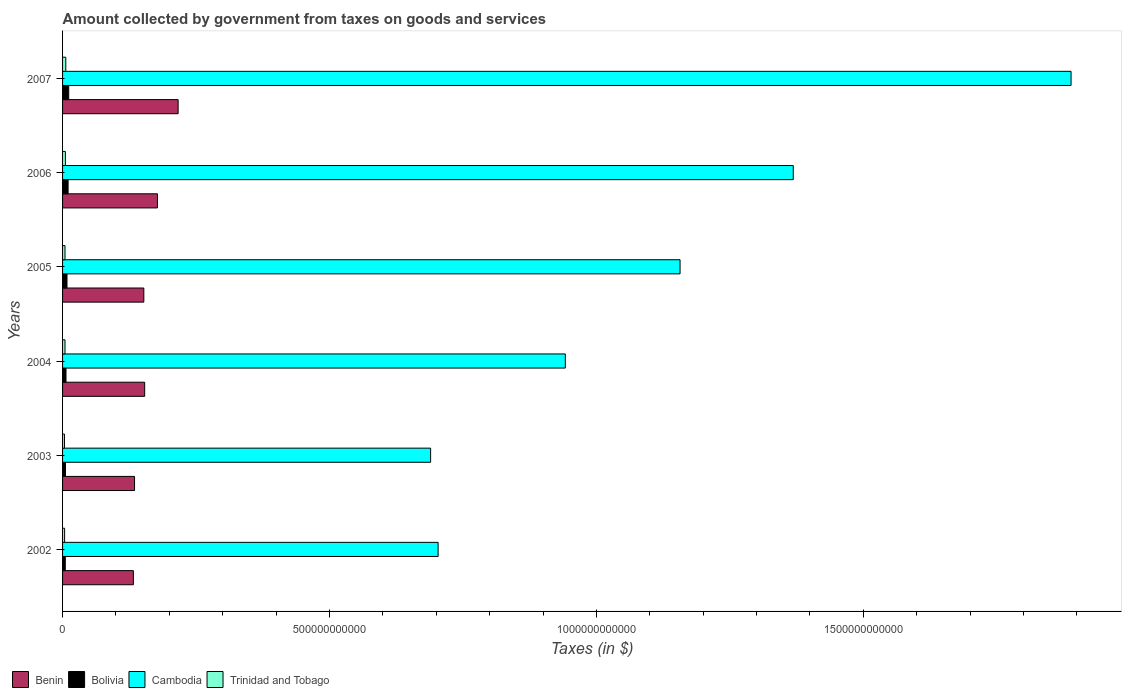How many groups of bars are there?
Ensure brevity in your answer.  6. How many bars are there on the 4th tick from the top?
Provide a short and direct response. 4. How many bars are there on the 3rd tick from the bottom?
Your answer should be very brief. 4. What is the amount collected by government from taxes on goods and services in Bolivia in 2002?
Provide a short and direct response. 5.11e+09. Across all years, what is the maximum amount collected by government from taxes on goods and services in Bolivia?
Provide a short and direct response. 1.15e+1. Across all years, what is the minimum amount collected by government from taxes on goods and services in Benin?
Your response must be concise. 1.33e+11. In which year was the amount collected by government from taxes on goods and services in Cambodia maximum?
Ensure brevity in your answer.  2007. What is the total amount collected by government from taxes on goods and services in Bolivia in the graph?
Your answer should be very brief. 4.72e+1. What is the difference between the amount collected by government from taxes on goods and services in Bolivia in 2003 and that in 2005?
Your answer should be compact. -2.85e+09. What is the difference between the amount collected by government from taxes on goods and services in Bolivia in 2007 and the amount collected by government from taxes on goods and services in Trinidad and Tobago in 2002?
Offer a very short reply. 7.73e+09. What is the average amount collected by government from taxes on goods and services in Benin per year?
Your answer should be compact. 1.61e+11. In the year 2003, what is the difference between the amount collected by government from taxes on goods and services in Cambodia and amount collected by government from taxes on goods and services in Trinidad and Tobago?
Offer a very short reply. 6.86e+11. In how many years, is the amount collected by government from taxes on goods and services in Cambodia greater than 400000000000 $?
Your answer should be compact. 6. What is the ratio of the amount collected by government from taxes on goods and services in Cambodia in 2003 to that in 2004?
Your answer should be compact. 0.73. Is the amount collected by government from taxes on goods and services in Cambodia in 2004 less than that in 2007?
Your answer should be compact. Yes. What is the difference between the highest and the second highest amount collected by government from taxes on goods and services in Trinidad and Tobago?
Ensure brevity in your answer.  7.52e+08. What is the difference between the highest and the lowest amount collected by government from taxes on goods and services in Bolivia?
Make the answer very short. 6.43e+09. In how many years, is the amount collected by government from taxes on goods and services in Cambodia greater than the average amount collected by government from taxes on goods and services in Cambodia taken over all years?
Offer a terse response. 3. Is it the case that in every year, the sum of the amount collected by government from taxes on goods and services in Cambodia and amount collected by government from taxes on goods and services in Bolivia is greater than the sum of amount collected by government from taxes on goods and services in Benin and amount collected by government from taxes on goods and services in Trinidad and Tobago?
Your answer should be very brief. Yes. What does the 4th bar from the top in 2004 represents?
Provide a succinct answer. Benin. What does the 1st bar from the bottom in 2004 represents?
Your answer should be very brief. Benin. Is it the case that in every year, the sum of the amount collected by government from taxes on goods and services in Bolivia and amount collected by government from taxes on goods and services in Trinidad and Tobago is greater than the amount collected by government from taxes on goods and services in Benin?
Give a very brief answer. No. Are all the bars in the graph horizontal?
Your answer should be very brief. Yes. What is the difference between two consecutive major ticks on the X-axis?
Offer a very short reply. 5.00e+11. Where does the legend appear in the graph?
Keep it short and to the point. Bottom left. How many legend labels are there?
Give a very brief answer. 4. What is the title of the graph?
Give a very brief answer. Amount collected by government from taxes on goods and services. What is the label or title of the X-axis?
Provide a succinct answer. Taxes (in $). What is the label or title of the Y-axis?
Keep it short and to the point. Years. What is the Taxes (in $) of Benin in 2002?
Your answer should be compact. 1.33e+11. What is the Taxes (in $) in Bolivia in 2002?
Keep it short and to the point. 5.11e+09. What is the Taxes (in $) in Cambodia in 2002?
Your answer should be compact. 7.04e+11. What is the Taxes (in $) in Trinidad and Tobago in 2002?
Give a very brief answer. 3.81e+09. What is the Taxes (in $) in Benin in 2003?
Keep it short and to the point. 1.35e+11. What is the Taxes (in $) in Bolivia in 2003?
Give a very brief answer. 5.45e+09. What is the Taxes (in $) in Cambodia in 2003?
Offer a terse response. 6.89e+11. What is the Taxes (in $) in Trinidad and Tobago in 2003?
Ensure brevity in your answer.  3.56e+09. What is the Taxes (in $) of Benin in 2004?
Offer a very short reply. 1.54e+11. What is the Taxes (in $) in Bolivia in 2004?
Keep it short and to the point. 6.44e+09. What is the Taxes (in $) in Cambodia in 2004?
Ensure brevity in your answer.  9.42e+11. What is the Taxes (in $) in Trinidad and Tobago in 2004?
Make the answer very short. 4.55e+09. What is the Taxes (in $) of Benin in 2005?
Keep it short and to the point. 1.52e+11. What is the Taxes (in $) of Bolivia in 2005?
Keep it short and to the point. 8.30e+09. What is the Taxes (in $) of Cambodia in 2005?
Provide a succinct answer. 1.16e+12. What is the Taxes (in $) of Trinidad and Tobago in 2005?
Your response must be concise. 4.56e+09. What is the Taxes (in $) in Benin in 2006?
Offer a very short reply. 1.78e+11. What is the Taxes (in $) in Bolivia in 2006?
Your response must be concise. 1.04e+1. What is the Taxes (in $) in Cambodia in 2006?
Give a very brief answer. 1.37e+12. What is the Taxes (in $) of Trinidad and Tobago in 2006?
Offer a very short reply. 5.29e+09. What is the Taxes (in $) of Benin in 2007?
Your answer should be compact. 2.16e+11. What is the Taxes (in $) in Bolivia in 2007?
Keep it short and to the point. 1.15e+1. What is the Taxes (in $) of Cambodia in 2007?
Give a very brief answer. 1.89e+12. What is the Taxes (in $) in Trinidad and Tobago in 2007?
Provide a short and direct response. 6.04e+09. Across all years, what is the maximum Taxes (in $) in Benin?
Your answer should be very brief. 2.16e+11. Across all years, what is the maximum Taxes (in $) of Bolivia?
Your response must be concise. 1.15e+1. Across all years, what is the maximum Taxes (in $) in Cambodia?
Ensure brevity in your answer.  1.89e+12. Across all years, what is the maximum Taxes (in $) of Trinidad and Tobago?
Ensure brevity in your answer.  6.04e+09. Across all years, what is the minimum Taxes (in $) in Benin?
Your response must be concise. 1.33e+11. Across all years, what is the minimum Taxes (in $) of Bolivia?
Your answer should be compact. 5.11e+09. Across all years, what is the minimum Taxes (in $) of Cambodia?
Provide a short and direct response. 6.89e+11. Across all years, what is the minimum Taxes (in $) in Trinidad and Tobago?
Your response must be concise. 3.56e+09. What is the total Taxes (in $) of Benin in the graph?
Your answer should be very brief. 9.68e+11. What is the total Taxes (in $) of Bolivia in the graph?
Provide a short and direct response. 4.72e+1. What is the total Taxes (in $) in Cambodia in the graph?
Your answer should be very brief. 6.75e+12. What is the total Taxes (in $) of Trinidad and Tobago in the graph?
Ensure brevity in your answer.  2.78e+1. What is the difference between the Taxes (in $) in Benin in 2002 and that in 2003?
Give a very brief answer. -2.19e+09. What is the difference between the Taxes (in $) of Bolivia in 2002 and that in 2003?
Give a very brief answer. -3.37e+08. What is the difference between the Taxes (in $) in Cambodia in 2002 and that in 2003?
Ensure brevity in your answer.  1.41e+1. What is the difference between the Taxes (in $) in Trinidad and Tobago in 2002 and that in 2003?
Make the answer very short. 2.54e+08. What is the difference between the Taxes (in $) of Benin in 2002 and that in 2004?
Offer a very short reply. -2.12e+1. What is the difference between the Taxes (in $) of Bolivia in 2002 and that in 2004?
Your response must be concise. -1.33e+09. What is the difference between the Taxes (in $) in Cambodia in 2002 and that in 2004?
Offer a very short reply. -2.38e+11. What is the difference between the Taxes (in $) of Trinidad and Tobago in 2002 and that in 2004?
Offer a very short reply. -7.41e+08. What is the difference between the Taxes (in $) of Benin in 2002 and that in 2005?
Offer a very short reply. -1.96e+1. What is the difference between the Taxes (in $) in Bolivia in 2002 and that in 2005?
Ensure brevity in your answer.  -3.19e+09. What is the difference between the Taxes (in $) in Cambodia in 2002 and that in 2005?
Your response must be concise. -4.53e+11. What is the difference between the Taxes (in $) of Trinidad and Tobago in 2002 and that in 2005?
Provide a succinct answer. -7.42e+08. What is the difference between the Taxes (in $) in Benin in 2002 and that in 2006?
Your answer should be very brief. -4.51e+1. What is the difference between the Taxes (in $) in Bolivia in 2002 and that in 2006?
Provide a short and direct response. -5.25e+09. What is the difference between the Taxes (in $) in Cambodia in 2002 and that in 2006?
Your answer should be very brief. -6.65e+11. What is the difference between the Taxes (in $) in Trinidad and Tobago in 2002 and that in 2006?
Offer a very short reply. -1.47e+09. What is the difference between the Taxes (in $) of Benin in 2002 and that in 2007?
Your response must be concise. -8.38e+1. What is the difference between the Taxes (in $) in Bolivia in 2002 and that in 2007?
Make the answer very short. -6.43e+09. What is the difference between the Taxes (in $) in Cambodia in 2002 and that in 2007?
Give a very brief answer. -1.19e+12. What is the difference between the Taxes (in $) in Trinidad and Tobago in 2002 and that in 2007?
Make the answer very short. -2.22e+09. What is the difference between the Taxes (in $) of Benin in 2003 and that in 2004?
Your response must be concise. -1.90e+1. What is the difference between the Taxes (in $) in Bolivia in 2003 and that in 2004?
Ensure brevity in your answer.  -9.93e+08. What is the difference between the Taxes (in $) in Cambodia in 2003 and that in 2004?
Make the answer very short. -2.52e+11. What is the difference between the Taxes (in $) in Trinidad and Tobago in 2003 and that in 2004?
Provide a succinct answer. -9.94e+08. What is the difference between the Taxes (in $) of Benin in 2003 and that in 2005?
Give a very brief answer. -1.74e+1. What is the difference between the Taxes (in $) of Bolivia in 2003 and that in 2005?
Ensure brevity in your answer.  -2.85e+09. What is the difference between the Taxes (in $) in Cambodia in 2003 and that in 2005?
Give a very brief answer. -4.67e+11. What is the difference between the Taxes (in $) in Trinidad and Tobago in 2003 and that in 2005?
Give a very brief answer. -9.95e+08. What is the difference between the Taxes (in $) in Benin in 2003 and that in 2006?
Your response must be concise. -4.29e+1. What is the difference between the Taxes (in $) of Bolivia in 2003 and that in 2006?
Your answer should be compact. -4.92e+09. What is the difference between the Taxes (in $) in Cambodia in 2003 and that in 2006?
Make the answer very short. -6.79e+11. What is the difference between the Taxes (in $) in Trinidad and Tobago in 2003 and that in 2006?
Keep it short and to the point. -1.73e+09. What is the difference between the Taxes (in $) in Benin in 2003 and that in 2007?
Offer a terse response. -8.16e+1. What is the difference between the Taxes (in $) in Bolivia in 2003 and that in 2007?
Give a very brief answer. -6.09e+09. What is the difference between the Taxes (in $) in Cambodia in 2003 and that in 2007?
Provide a short and direct response. -1.20e+12. What is the difference between the Taxes (in $) of Trinidad and Tobago in 2003 and that in 2007?
Offer a terse response. -2.48e+09. What is the difference between the Taxes (in $) in Benin in 2004 and that in 2005?
Provide a short and direct response. 1.60e+09. What is the difference between the Taxes (in $) of Bolivia in 2004 and that in 2005?
Ensure brevity in your answer.  -1.86e+09. What is the difference between the Taxes (in $) of Cambodia in 2004 and that in 2005?
Make the answer very short. -2.15e+11. What is the difference between the Taxes (in $) in Trinidad and Tobago in 2004 and that in 2005?
Provide a succinct answer. -1.20e+06. What is the difference between the Taxes (in $) of Benin in 2004 and that in 2006?
Give a very brief answer. -2.39e+1. What is the difference between the Taxes (in $) of Bolivia in 2004 and that in 2006?
Make the answer very short. -3.92e+09. What is the difference between the Taxes (in $) of Cambodia in 2004 and that in 2006?
Provide a succinct answer. -4.27e+11. What is the difference between the Taxes (in $) of Trinidad and Tobago in 2004 and that in 2006?
Offer a terse response. -7.32e+08. What is the difference between the Taxes (in $) in Benin in 2004 and that in 2007?
Your response must be concise. -6.27e+1. What is the difference between the Taxes (in $) in Bolivia in 2004 and that in 2007?
Make the answer very short. -5.10e+09. What is the difference between the Taxes (in $) of Cambodia in 2004 and that in 2007?
Your response must be concise. -9.47e+11. What is the difference between the Taxes (in $) in Trinidad and Tobago in 2004 and that in 2007?
Provide a short and direct response. -1.48e+09. What is the difference between the Taxes (in $) in Benin in 2005 and that in 2006?
Give a very brief answer. -2.55e+1. What is the difference between the Taxes (in $) of Bolivia in 2005 and that in 2006?
Offer a terse response. -2.06e+09. What is the difference between the Taxes (in $) of Cambodia in 2005 and that in 2006?
Your answer should be very brief. -2.12e+11. What is the difference between the Taxes (in $) of Trinidad and Tobago in 2005 and that in 2006?
Offer a terse response. -7.30e+08. What is the difference between the Taxes (in $) in Benin in 2005 and that in 2007?
Offer a very short reply. -6.43e+1. What is the difference between the Taxes (in $) in Bolivia in 2005 and that in 2007?
Provide a succinct answer. -3.24e+09. What is the difference between the Taxes (in $) of Cambodia in 2005 and that in 2007?
Your response must be concise. -7.32e+11. What is the difference between the Taxes (in $) in Trinidad and Tobago in 2005 and that in 2007?
Give a very brief answer. -1.48e+09. What is the difference between the Taxes (in $) in Benin in 2006 and that in 2007?
Provide a succinct answer. -3.87e+1. What is the difference between the Taxes (in $) in Bolivia in 2006 and that in 2007?
Provide a succinct answer. -1.18e+09. What is the difference between the Taxes (in $) in Cambodia in 2006 and that in 2007?
Provide a succinct answer. -5.20e+11. What is the difference between the Taxes (in $) of Trinidad and Tobago in 2006 and that in 2007?
Your answer should be very brief. -7.52e+08. What is the difference between the Taxes (in $) of Benin in 2002 and the Taxes (in $) of Bolivia in 2003?
Ensure brevity in your answer.  1.27e+11. What is the difference between the Taxes (in $) of Benin in 2002 and the Taxes (in $) of Cambodia in 2003?
Your answer should be compact. -5.57e+11. What is the difference between the Taxes (in $) in Benin in 2002 and the Taxes (in $) in Trinidad and Tobago in 2003?
Offer a very short reply. 1.29e+11. What is the difference between the Taxes (in $) in Bolivia in 2002 and the Taxes (in $) in Cambodia in 2003?
Offer a terse response. -6.84e+11. What is the difference between the Taxes (in $) in Bolivia in 2002 and the Taxes (in $) in Trinidad and Tobago in 2003?
Keep it short and to the point. 1.55e+09. What is the difference between the Taxes (in $) of Cambodia in 2002 and the Taxes (in $) of Trinidad and Tobago in 2003?
Provide a short and direct response. 7.00e+11. What is the difference between the Taxes (in $) of Benin in 2002 and the Taxes (in $) of Bolivia in 2004?
Ensure brevity in your answer.  1.26e+11. What is the difference between the Taxes (in $) of Benin in 2002 and the Taxes (in $) of Cambodia in 2004?
Your response must be concise. -8.09e+11. What is the difference between the Taxes (in $) in Benin in 2002 and the Taxes (in $) in Trinidad and Tobago in 2004?
Give a very brief answer. 1.28e+11. What is the difference between the Taxes (in $) of Bolivia in 2002 and the Taxes (in $) of Cambodia in 2004?
Your answer should be compact. -9.37e+11. What is the difference between the Taxes (in $) of Bolivia in 2002 and the Taxes (in $) of Trinidad and Tobago in 2004?
Ensure brevity in your answer.  5.55e+08. What is the difference between the Taxes (in $) in Cambodia in 2002 and the Taxes (in $) in Trinidad and Tobago in 2004?
Make the answer very short. 6.99e+11. What is the difference between the Taxes (in $) of Benin in 2002 and the Taxes (in $) of Bolivia in 2005?
Provide a succinct answer. 1.24e+11. What is the difference between the Taxes (in $) in Benin in 2002 and the Taxes (in $) in Cambodia in 2005?
Your response must be concise. -1.02e+12. What is the difference between the Taxes (in $) of Benin in 2002 and the Taxes (in $) of Trinidad and Tobago in 2005?
Offer a very short reply. 1.28e+11. What is the difference between the Taxes (in $) of Bolivia in 2002 and the Taxes (in $) of Cambodia in 2005?
Your answer should be compact. -1.15e+12. What is the difference between the Taxes (in $) in Bolivia in 2002 and the Taxes (in $) in Trinidad and Tobago in 2005?
Provide a succinct answer. 5.54e+08. What is the difference between the Taxes (in $) of Cambodia in 2002 and the Taxes (in $) of Trinidad and Tobago in 2005?
Provide a short and direct response. 6.99e+11. What is the difference between the Taxes (in $) of Benin in 2002 and the Taxes (in $) of Bolivia in 2006?
Keep it short and to the point. 1.22e+11. What is the difference between the Taxes (in $) of Benin in 2002 and the Taxes (in $) of Cambodia in 2006?
Provide a short and direct response. -1.24e+12. What is the difference between the Taxes (in $) of Benin in 2002 and the Taxes (in $) of Trinidad and Tobago in 2006?
Provide a succinct answer. 1.27e+11. What is the difference between the Taxes (in $) in Bolivia in 2002 and the Taxes (in $) in Cambodia in 2006?
Your response must be concise. -1.36e+12. What is the difference between the Taxes (in $) of Bolivia in 2002 and the Taxes (in $) of Trinidad and Tobago in 2006?
Your answer should be compact. -1.77e+08. What is the difference between the Taxes (in $) of Cambodia in 2002 and the Taxes (in $) of Trinidad and Tobago in 2006?
Your response must be concise. 6.98e+11. What is the difference between the Taxes (in $) of Benin in 2002 and the Taxes (in $) of Bolivia in 2007?
Offer a terse response. 1.21e+11. What is the difference between the Taxes (in $) of Benin in 2002 and the Taxes (in $) of Cambodia in 2007?
Make the answer very short. -1.76e+12. What is the difference between the Taxes (in $) of Benin in 2002 and the Taxes (in $) of Trinidad and Tobago in 2007?
Your response must be concise. 1.27e+11. What is the difference between the Taxes (in $) of Bolivia in 2002 and the Taxes (in $) of Cambodia in 2007?
Offer a terse response. -1.88e+12. What is the difference between the Taxes (in $) of Bolivia in 2002 and the Taxes (in $) of Trinidad and Tobago in 2007?
Your answer should be very brief. -9.29e+08. What is the difference between the Taxes (in $) in Cambodia in 2002 and the Taxes (in $) in Trinidad and Tobago in 2007?
Give a very brief answer. 6.97e+11. What is the difference between the Taxes (in $) of Benin in 2003 and the Taxes (in $) of Bolivia in 2004?
Your answer should be compact. 1.28e+11. What is the difference between the Taxes (in $) of Benin in 2003 and the Taxes (in $) of Cambodia in 2004?
Keep it short and to the point. -8.07e+11. What is the difference between the Taxes (in $) of Benin in 2003 and the Taxes (in $) of Trinidad and Tobago in 2004?
Offer a very short reply. 1.30e+11. What is the difference between the Taxes (in $) in Bolivia in 2003 and the Taxes (in $) in Cambodia in 2004?
Your response must be concise. -9.36e+11. What is the difference between the Taxes (in $) of Bolivia in 2003 and the Taxes (in $) of Trinidad and Tobago in 2004?
Provide a succinct answer. 8.92e+08. What is the difference between the Taxes (in $) of Cambodia in 2003 and the Taxes (in $) of Trinidad and Tobago in 2004?
Your answer should be compact. 6.85e+11. What is the difference between the Taxes (in $) in Benin in 2003 and the Taxes (in $) in Bolivia in 2005?
Give a very brief answer. 1.27e+11. What is the difference between the Taxes (in $) of Benin in 2003 and the Taxes (in $) of Cambodia in 2005?
Your response must be concise. -1.02e+12. What is the difference between the Taxes (in $) in Benin in 2003 and the Taxes (in $) in Trinidad and Tobago in 2005?
Offer a very short reply. 1.30e+11. What is the difference between the Taxes (in $) in Bolivia in 2003 and the Taxes (in $) in Cambodia in 2005?
Offer a terse response. -1.15e+12. What is the difference between the Taxes (in $) of Bolivia in 2003 and the Taxes (in $) of Trinidad and Tobago in 2005?
Ensure brevity in your answer.  8.91e+08. What is the difference between the Taxes (in $) in Cambodia in 2003 and the Taxes (in $) in Trinidad and Tobago in 2005?
Provide a succinct answer. 6.85e+11. What is the difference between the Taxes (in $) in Benin in 2003 and the Taxes (in $) in Bolivia in 2006?
Keep it short and to the point. 1.24e+11. What is the difference between the Taxes (in $) in Benin in 2003 and the Taxes (in $) in Cambodia in 2006?
Ensure brevity in your answer.  -1.23e+12. What is the difference between the Taxes (in $) of Benin in 2003 and the Taxes (in $) of Trinidad and Tobago in 2006?
Provide a succinct answer. 1.30e+11. What is the difference between the Taxes (in $) in Bolivia in 2003 and the Taxes (in $) in Cambodia in 2006?
Give a very brief answer. -1.36e+12. What is the difference between the Taxes (in $) in Bolivia in 2003 and the Taxes (in $) in Trinidad and Tobago in 2006?
Ensure brevity in your answer.  1.60e+08. What is the difference between the Taxes (in $) in Cambodia in 2003 and the Taxes (in $) in Trinidad and Tobago in 2006?
Give a very brief answer. 6.84e+11. What is the difference between the Taxes (in $) of Benin in 2003 and the Taxes (in $) of Bolivia in 2007?
Offer a very short reply. 1.23e+11. What is the difference between the Taxes (in $) of Benin in 2003 and the Taxes (in $) of Cambodia in 2007?
Your answer should be compact. -1.75e+12. What is the difference between the Taxes (in $) of Benin in 2003 and the Taxes (in $) of Trinidad and Tobago in 2007?
Your answer should be compact. 1.29e+11. What is the difference between the Taxes (in $) of Bolivia in 2003 and the Taxes (in $) of Cambodia in 2007?
Offer a very short reply. -1.88e+12. What is the difference between the Taxes (in $) in Bolivia in 2003 and the Taxes (in $) in Trinidad and Tobago in 2007?
Your answer should be very brief. -5.92e+08. What is the difference between the Taxes (in $) of Cambodia in 2003 and the Taxes (in $) of Trinidad and Tobago in 2007?
Give a very brief answer. 6.83e+11. What is the difference between the Taxes (in $) of Benin in 2004 and the Taxes (in $) of Bolivia in 2005?
Provide a succinct answer. 1.46e+11. What is the difference between the Taxes (in $) in Benin in 2004 and the Taxes (in $) in Cambodia in 2005?
Make the answer very short. -1.00e+12. What is the difference between the Taxes (in $) in Benin in 2004 and the Taxes (in $) in Trinidad and Tobago in 2005?
Make the answer very short. 1.49e+11. What is the difference between the Taxes (in $) in Bolivia in 2004 and the Taxes (in $) in Cambodia in 2005?
Your response must be concise. -1.15e+12. What is the difference between the Taxes (in $) of Bolivia in 2004 and the Taxes (in $) of Trinidad and Tobago in 2005?
Offer a very short reply. 1.88e+09. What is the difference between the Taxes (in $) of Cambodia in 2004 and the Taxes (in $) of Trinidad and Tobago in 2005?
Offer a terse response. 9.37e+11. What is the difference between the Taxes (in $) in Benin in 2004 and the Taxes (in $) in Bolivia in 2006?
Offer a terse response. 1.43e+11. What is the difference between the Taxes (in $) of Benin in 2004 and the Taxes (in $) of Cambodia in 2006?
Your answer should be compact. -1.21e+12. What is the difference between the Taxes (in $) of Benin in 2004 and the Taxes (in $) of Trinidad and Tobago in 2006?
Provide a succinct answer. 1.49e+11. What is the difference between the Taxes (in $) in Bolivia in 2004 and the Taxes (in $) in Cambodia in 2006?
Offer a very short reply. -1.36e+12. What is the difference between the Taxes (in $) in Bolivia in 2004 and the Taxes (in $) in Trinidad and Tobago in 2006?
Offer a terse response. 1.15e+09. What is the difference between the Taxes (in $) of Cambodia in 2004 and the Taxes (in $) of Trinidad and Tobago in 2006?
Provide a succinct answer. 9.36e+11. What is the difference between the Taxes (in $) of Benin in 2004 and the Taxes (in $) of Bolivia in 2007?
Give a very brief answer. 1.42e+11. What is the difference between the Taxes (in $) of Benin in 2004 and the Taxes (in $) of Cambodia in 2007?
Keep it short and to the point. -1.74e+12. What is the difference between the Taxes (in $) of Benin in 2004 and the Taxes (in $) of Trinidad and Tobago in 2007?
Give a very brief answer. 1.48e+11. What is the difference between the Taxes (in $) of Bolivia in 2004 and the Taxes (in $) of Cambodia in 2007?
Give a very brief answer. -1.88e+12. What is the difference between the Taxes (in $) of Bolivia in 2004 and the Taxes (in $) of Trinidad and Tobago in 2007?
Ensure brevity in your answer.  4.02e+08. What is the difference between the Taxes (in $) in Cambodia in 2004 and the Taxes (in $) in Trinidad and Tobago in 2007?
Your answer should be very brief. 9.36e+11. What is the difference between the Taxes (in $) of Benin in 2005 and the Taxes (in $) of Bolivia in 2006?
Make the answer very short. 1.42e+11. What is the difference between the Taxes (in $) in Benin in 2005 and the Taxes (in $) in Cambodia in 2006?
Offer a very short reply. -1.22e+12. What is the difference between the Taxes (in $) of Benin in 2005 and the Taxes (in $) of Trinidad and Tobago in 2006?
Give a very brief answer. 1.47e+11. What is the difference between the Taxes (in $) of Bolivia in 2005 and the Taxes (in $) of Cambodia in 2006?
Keep it short and to the point. -1.36e+12. What is the difference between the Taxes (in $) of Bolivia in 2005 and the Taxes (in $) of Trinidad and Tobago in 2006?
Keep it short and to the point. 3.01e+09. What is the difference between the Taxes (in $) in Cambodia in 2005 and the Taxes (in $) in Trinidad and Tobago in 2006?
Keep it short and to the point. 1.15e+12. What is the difference between the Taxes (in $) of Benin in 2005 and the Taxes (in $) of Bolivia in 2007?
Your answer should be compact. 1.41e+11. What is the difference between the Taxes (in $) of Benin in 2005 and the Taxes (in $) of Cambodia in 2007?
Provide a short and direct response. -1.74e+12. What is the difference between the Taxes (in $) in Benin in 2005 and the Taxes (in $) in Trinidad and Tobago in 2007?
Make the answer very short. 1.46e+11. What is the difference between the Taxes (in $) of Bolivia in 2005 and the Taxes (in $) of Cambodia in 2007?
Provide a succinct answer. -1.88e+12. What is the difference between the Taxes (in $) in Bolivia in 2005 and the Taxes (in $) in Trinidad and Tobago in 2007?
Your answer should be compact. 2.26e+09. What is the difference between the Taxes (in $) of Cambodia in 2005 and the Taxes (in $) of Trinidad and Tobago in 2007?
Make the answer very short. 1.15e+12. What is the difference between the Taxes (in $) of Benin in 2006 and the Taxes (in $) of Bolivia in 2007?
Make the answer very short. 1.66e+11. What is the difference between the Taxes (in $) in Benin in 2006 and the Taxes (in $) in Cambodia in 2007?
Ensure brevity in your answer.  -1.71e+12. What is the difference between the Taxes (in $) of Benin in 2006 and the Taxes (in $) of Trinidad and Tobago in 2007?
Offer a terse response. 1.72e+11. What is the difference between the Taxes (in $) in Bolivia in 2006 and the Taxes (in $) in Cambodia in 2007?
Keep it short and to the point. -1.88e+12. What is the difference between the Taxes (in $) in Bolivia in 2006 and the Taxes (in $) in Trinidad and Tobago in 2007?
Your answer should be very brief. 4.32e+09. What is the difference between the Taxes (in $) in Cambodia in 2006 and the Taxes (in $) in Trinidad and Tobago in 2007?
Your answer should be compact. 1.36e+12. What is the average Taxes (in $) of Benin per year?
Offer a terse response. 1.61e+11. What is the average Taxes (in $) of Bolivia per year?
Make the answer very short. 7.87e+09. What is the average Taxes (in $) of Cambodia per year?
Your response must be concise. 1.12e+12. What is the average Taxes (in $) in Trinidad and Tobago per year?
Keep it short and to the point. 4.63e+09. In the year 2002, what is the difference between the Taxes (in $) of Benin and Taxes (in $) of Bolivia?
Your answer should be very brief. 1.28e+11. In the year 2002, what is the difference between the Taxes (in $) of Benin and Taxes (in $) of Cambodia?
Give a very brief answer. -5.71e+11. In the year 2002, what is the difference between the Taxes (in $) of Benin and Taxes (in $) of Trinidad and Tobago?
Your response must be concise. 1.29e+11. In the year 2002, what is the difference between the Taxes (in $) of Bolivia and Taxes (in $) of Cambodia?
Offer a terse response. -6.98e+11. In the year 2002, what is the difference between the Taxes (in $) in Bolivia and Taxes (in $) in Trinidad and Tobago?
Offer a terse response. 1.30e+09. In the year 2002, what is the difference between the Taxes (in $) in Cambodia and Taxes (in $) in Trinidad and Tobago?
Offer a very short reply. 7.00e+11. In the year 2003, what is the difference between the Taxes (in $) in Benin and Taxes (in $) in Bolivia?
Give a very brief answer. 1.29e+11. In the year 2003, what is the difference between the Taxes (in $) of Benin and Taxes (in $) of Cambodia?
Provide a succinct answer. -5.55e+11. In the year 2003, what is the difference between the Taxes (in $) of Benin and Taxes (in $) of Trinidad and Tobago?
Provide a short and direct response. 1.31e+11. In the year 2003, what is the difference between the Taxes (in $) in Bolivia and Taxes (in $) in Cambodia?
Your answer should be very brief. -6.84e+11. In the year 2003, what is the difference between the Taxes (in $) of Bolivia and Taxes (in $) of Trinidad and Tobago?
Offer a terse response. 1.89e+09. In the year 2003, what is the difference between the Taxes (in $) in Cambodia and Taxes (in $) in Trinidad and Tobago?
Make the answer very short. 6.86e+11. In the year 2004, what is the difference between the Taxes (in $) of Benin and Taxes (in $) of Bolivia?
Offer a terse response. 1.47e+11. In the year 2004, what is the difference between the Taxes (in $) in Benin and Taxes (in $) in Cambodia?
Your answer should be very brief. -7.88e+11. In the year 2004, what is the difference between the Taxes (in $) in Benin and Taxes (in $) in Trinidad and Tobago?
Provide a short and direct response. 1.49e+11. In the year 2004, what is the difference between the Taxes (in $) in Bolivia and Taxes (in $) in Cambodia?
Ensure brevity in your answer.  -9.35e+11. In the year 2004, what is the difference between the Taxes (in $) of Bolivia and Taxes (in $) of Trinidad and Tobago?
Your answer should be very brief. 1.88e+09. In the year 2004, what is the difference between the Taxes (in $) of Cambodia and Taxes (in $) of Trinidad and Tobago?
Give a very brief answer. 9.37e+11. In the year 2005, what is the difference between the Taxes (in $) in Benin and Taxes (in $) in Bolivia?
Provide a short and direct response. 1.44e+11. In the year 2005, what is the difference between the Taxes (in $) of Benin and Taxes (in $) of Cambodia?
Your answer should be very brief. -1.00e+12. In the year 2005, what is the difference between the Taxes (in $) in Benin and Taxes (in $) in Trinidad and Tobago?
Provide a succinct answer. 1.48e+11. In the year 2005, what is the difference between the Taxes (in $) in Bolivia and Taxes (in $) in Cambodia?
Your answer should be compact. -1.15e+12. In the year 2005, what is the difference between the Taxes (in $) in Bolivia and Taxes (in $) in Trinidad and Tobago?
Keep it short and to the point. 3.74e+09. In the year 2005, what is the difference between the Taxes (in $) of Cambodia and Taxes (in $) of Trinidad and Tobago?
Ensure brevity in your answer.  1.15e+12. In the year 2006, what is the difference between the Taxes (in $) of Benin and Taxes (in $) of Bolivia?
Your answer should be compact. 1.67e+11. In the year 2006, what is the difference between the Taxes (in $) in Benin and Taxes (in $) in Cambodia?
Offer a very short reply. -1.19e+12. In the year 2006, what is the difference between the Taxes (in $) of Benin and Taxes (in $) of Trinidad and Tobago?
Provide a succinct answer. 1.72e+11. In the year 2006, what is the difference between the Taxes (in $) in Bolivia and Taxes (in $) in Cambodia?
Offer a terse response. -1.36e+12. In the year 2006, what is the difference between the Taxes (in $) of Bolivia and Taxes (in $) of Trinidad and Tobago?
Provide a short and direct response. 5.08e+09. In the year 2006, what is the difference between the Taxes (in $) of Cambodia and Taxes (in $) of Trinidad and Tobago?
Ensure brevity in your answer.  1.36e+12. In the year 2007, what is the difference between the Taxes (in $) of Benin and Taxes (in $) of Bolivia?
Give a very brief answer. 2.05e+11. In the year 2007, what is the difference between the Taxes (in $) of Benin and Taxes (in $) of Cambodia?
Your response must be concise. -1.67e+12. In the year 2007, what is the difference between the Taxes (in $) in Benin and Taxes (in $) in Trinidad and Tobago?
Make the answer very short. 2.10e+11. In the year 2007, what is the difference between the Taxes (in $) of Bolivia and Taxes (in $) of Cambodia?
Ensure brevity in your answer.  -1.88e+12. In the year 2007, what is the difference between the Taxes (in $) in Bolivia and Taxes (in $) in Trinidad and Tobago?
Keep it short and to the point. 5.50e+09. In the year 2007, what is the difference between the Taxes (in $) in Cambodia and Taxes (in $) in Trinidad and Tobago?
Give a very brief answer. 1.88e+12. What is the ratio of the Taxes (in $) of Benin in 2002 to that in 2003?
Your answer should be very brief. 0.98. What is the ratio of the Taxes (in $) of Bolivia in 2002 to that in 2003?
Offer a very short reply. 0.94. What is the ratio of the Taxes (in $) in Cambodia in 2002 to that in 2003?
Provide a succinct answer. 1.02. What is the ratio of the Taxes (in $) in Trinidad and Tobago in 2002 to that in 2003?
Offer a very short reply. 1.07. What is the ratio of the Taxes (in $) in Benin in 2002 to that in 2004?
Keep it short and to the point. 0.86. What is the ratio of the Taxes (in $) of Bolivia in 2002 to that in 2004?
Ensure brevity in your answer.  0.79. What is the ratio of the Taxes (in $) of Cambodia in 2002 to that in 2004?
Your answer should be very brief. 0.75. What is the ratio of the Taxes (in $) in Trinidad and Tobago in 2002 to that in 2004?
Your answer should be very brief. 0.84. What is the ratio of the Taxes (in $) of Benin in 2002 to that in 2005?
Your response must be concise. 0.87. What is the ratio of the Taxes (in $) of Bolivia in 2002 to that in 2005?
Your answer should be very brief. 0.62. What is the ratio of the Taxes (in $) in Cambodia in 2002 to that in 2005?
Provide a succinct answer. 0.61. What is the ratio of the Taxes (in $) of Trinidad and Tobago in 2002 to that in 2005?
Offer a very short reply. 0.84. What is the ratio of the Taxes (in $) of Benin in 2002 to that in 2006?
Your response must be concise. 0.75. What is the ratio of the Taxes (in $) in Bolivia in 2002 to that in 2006?
Keep it short and to the point. 0.49. What is the ratio of the Taxes (in $) of Cambodia in 2002 to that in 2006?
Provide a short and direct response. 0.51. What is the ratio of the Taxes (in $) in Trinidad and Tobago in 2002 to that in 2006?
Ensure brevity in your answer.  0.72. What is the ratio of the Taxes (in $) in Benin in 2002 to that in 2007?
Your answer should be very brief. 0.61. What is the ratio of the Taxes (in $) in Bolivia in 2002 to that in 2007?
Provide a short and direct response. 0.44. What is the ratio of the Taxes (in $) of Cambodia in 2002 to that in 2007?
Offer a terse response. 0.37. What is the ratio of the Taxes (in $) in Trinidad and Tobago in 2002 to that in 2007?
Your answer should be compact. 0.63. What is the ratio of the Taxes (in $) in Benin in 2003 to that in 2004?
Your answer should be very brief. 0.88. What is the ratio of the Taxes (in $) in Bolivia in 2003 to that in 2004?
Offer a terse response. 0.85. What is the ratio of the Taxes (in $) of Cambodia in 2003 to that in 2004?
Your answer should be very brief. 0.73. What is the ratio of the Taxes (in $) in Trinidad and Tobago in 2003 to that in 2004?
Keep it short and to the point. 0.78. What is the ratio of the Taxes (in $) in Benin in 2003 to that in 2005?
Give a very brief answer. 0.89. What is the ratio of the Taxes (in $) of Bolivia in 2003 to that in 2005?
Give a very brief answer. 0.66. What is the ratio of the Taxes (in $) in Cambodia in 2003 to that in 2005?
Your response must be concise. 0.6. What is the ratio of the Taxes (in $) of Trinidad and Tobago in 2003 to that in 2005?
Your response must be concise. 0.78. What is the ratio of the Taxes (in $) in Benin in 2003 to that in 2006?
Your answer should be compact. 0.76. What is the ratio of the Taxes (in $) of Bolivia in 2003 to that in 2006?
Provide a succinct answer. 0.53. What is the ratio of the Taxes (in $) of Cambodia in 2003 to that in 2006?
Provide a short and direct response. 0.5. What is the ratio of the Taxes (in $) of Trinidad and Tobago in 2003 to that in 2006?
Offer a terse response. 0.67. What is the ratio of the Taxes (in $) in Benin in 2003 to that in 2007?
Your response must be concise. 0.62. What is the ratio of the Taxes (in $) in Bolivia in 2003 to that in 2007?
Offer a terse response. 0.47. What is the ratio of the Taxes (in $) of Cambodia in 2003 to that in 2007?
Your answer should be very brief. 0.36. What is the ratio of the Taxes (in $) in Trinidad and Tobago in 2003 to that in 2007?
Offer a very short reply. 0.59. What is the ratio of the Taxes (in $) of Benin in 2004 to that in 2005?
Provide a succinct answer. 1.01. What is the ratio of the Taxes (in $) in Bolivia in 2004 to that in 2005?
Your answer should be compact. 0.78. What is the ratio of the Taxes (in $) of Cambodia in 2004 to that in 2005?
Your answer should be very brief. 0.81. What is the ratio of the Taxes (in $) of Benin in 2004 to that in 2006?
Provide a succinct answer. 0.87. What is the ratio of the Taxes (in $) of Bolivia in 2004 to that in 2006?
Give a very brief answer. 0.62. What is the ratio of the Taxes (in $) of Cambodia in 2004 to that in 2006?
Make the answer very short. 0.69. What is the ratio of the Taxes (in $) in Trinidad and Tobago in 2004 to that in 2006?
Your answer should be very brief. 0.86. What is the ratio of the Taxes (in $) of Benin in 2004 to that in 2007?
Offer a very short reply. 0.71. What is the ratio of the Taxes (in $) in Bolivia in 2004 to that in 2007?
Offer a terse response. 0.56. What is the ratio of the Taxes (in $) in Cambodia in 2004 to that in 2007?
Your response must be concise. 0.5. What is the ratio of the Taxes (in $) of Trinidad and Tobago in 2004 to that in 2007?
Your response must be concise. 0.75. What is the ratio of the Taxes (in $) in Benin in 2005 to that in 2006?
Keep it short and to the point. 0.86. What is the ratio of the Taxes (in $) in Bolivia in 2005 to that in 2006?
Give a very brief answer. 0.8. What is the ratio of the Taxes (in $) of Cambodia in 2005 to that in 2006?
Keep it short and to the point. 0.85. What is the ratio of the Taxes (in $) in Trinidad and Tobago in 2005 to that in 2006?
Offer a terse response. 0.86. What is the ratio of the Taxes (in $) of Benin in 2005 to that in 2007?
Offer a terse response. 0.7. What is the ratio of the Taxes (in $) of Bolivia in 2005 to that in 2007?
Provide a succinct answer. 0.72. What is the ratio of the Taxes (in $) of Cambodia in 2005 to that in 2007?
Your answer should be compact. 0.61. What is the ratio of the Taxes (in $) of Trinidad and Tobago in 2005 to that in 2007?
Provide a succinct answer. 0.75. What is the ratio of the Taxes (in $) in Benin in 2006 to that in 2007?
Give a very brief answer. 0.82. What is the ratio of the Taxes (in $) in Bolivia in 2006 to that in 2007?
Your answer should be very brief. 0.9. What is the ratio of the Taxes (in $) in Cambodia in 2006 to that in 2007?
Your response must be concise. 0.72. What is the ratio of the Taxes (in $) in Trinidad and Tobago in 2006 to that in 2007?
Offer a terse response. 0.88. What is the difference between the highest and the second highest Taxes (in $) of Benin?
Keep it short and to the point. 3.87e+1. What is the difference between the highest and the second highest Taxes (in $) in Bolivia?
Keep it short and to the point. 1.18e+09. What is the difference between the highest and the second highest Taxes (in $) of Cambodia?
Provide a short and direct response. 5.20e+11. What is the difference between the highest and the second highest Taxes (in $) of Trinidad and Tobago?
Ensure brevity in your answer.  7.52e+08. What is the difference between the highest and the lowest Taxes (in $) in Benin?
Make the answer very short. 8.38e+1. What is the difference between the highest and the lowest Taxes (in $) in Bolivia?
Ensure brevity in your answer.  6.43e+09. What is the difference between the highest and the lowest Taxes (in $) of Cambodia?
Offer a terse response. 1.20e+12. What is the difference between the highest and the lowest Taxes (in $) of Trinidad and Tobago?
Your answer should be compact. 2.48e+09. 